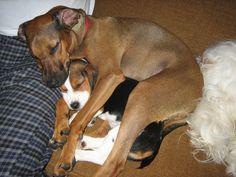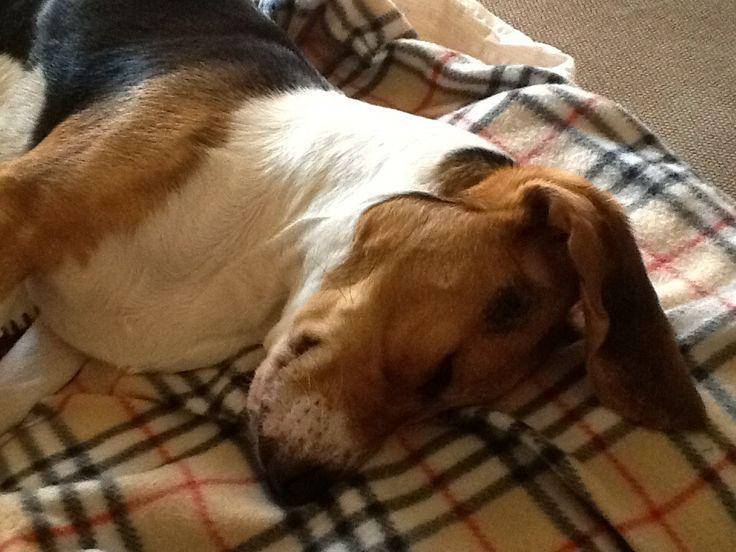The first image is the image on the left, the second image is the image on the right. For the images shown, is this caption "The dogs are lying in the same direction." true? Answer yes or no. No. 